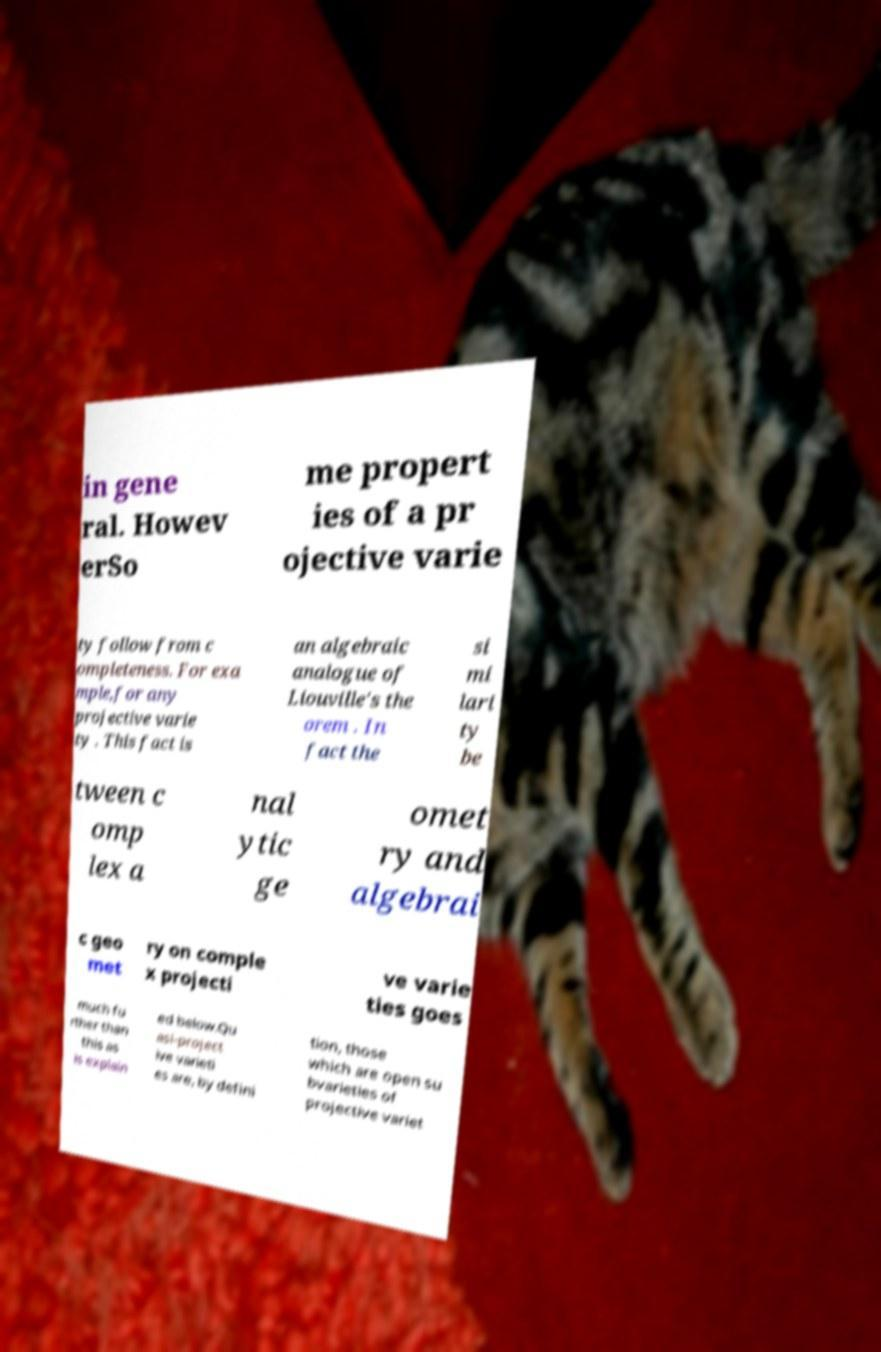For documentation purposes, I need the text within this image transcribed. Could you provide that? in gene ral. Howev erSo me propert ies of a pr ojective varie ty follow from c ompleteness. For exa mple,for any projective varie ty . This fact is an algebraic analogue of Liouville's the orem . In fact the si mi lari ty be tween c omp lex a nal ytic ge omet ry and algebrai c geo met ry on comple x projecti ve varie ties goes much fu rther than this as is explain ed below.Qu asi-project ive varieti es are, by defini tion, those which are open su bvarieties of projective variet 